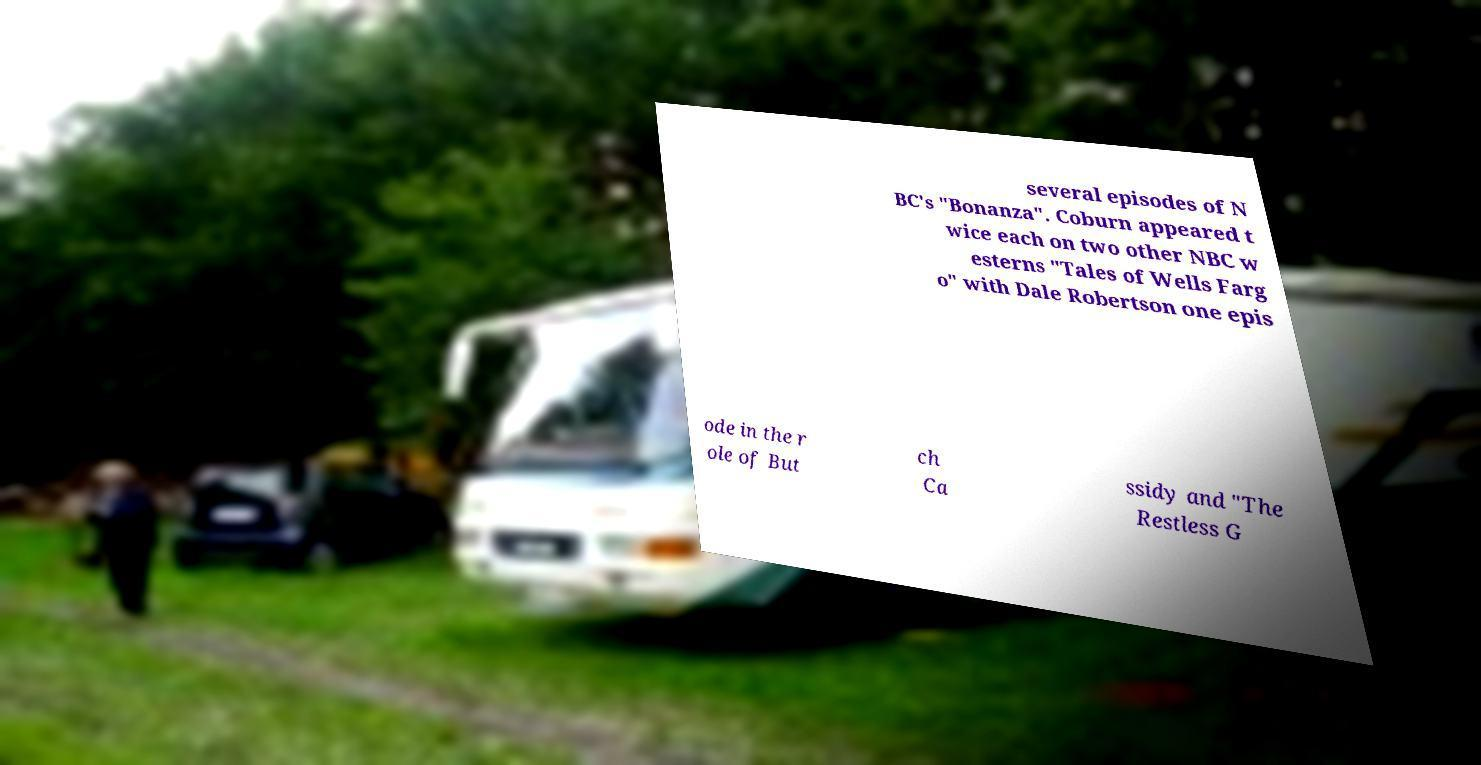There's text embedded in this image that I need extracted. Can you transcribe it verbatim? several episodes of N BC's "Bonanza". Coburn appeared t wice each on two other NBC w esterns "Tales of Wells Farg o" with Dale Robertson one epis ode in the r ole of But ch Ca ssidy and "The Restless G 